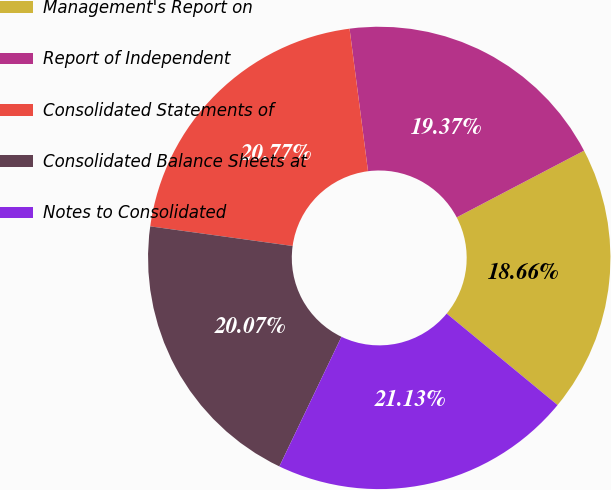Convert chart. <chart><loc_0><loc_0><loc_500><loc_500><pie_chart><fcel>Management's Report on<fcel>Report of Independent<fcel>Consolidated Statements of<fcel>Consolidated Balance Sheets at<fcel>Notes to Consolidated<nl><fcel>18.66%<fcel>19.37%<fcel>20.77%<fcel>20.07%<fcel>21.13%<nl></chart> 